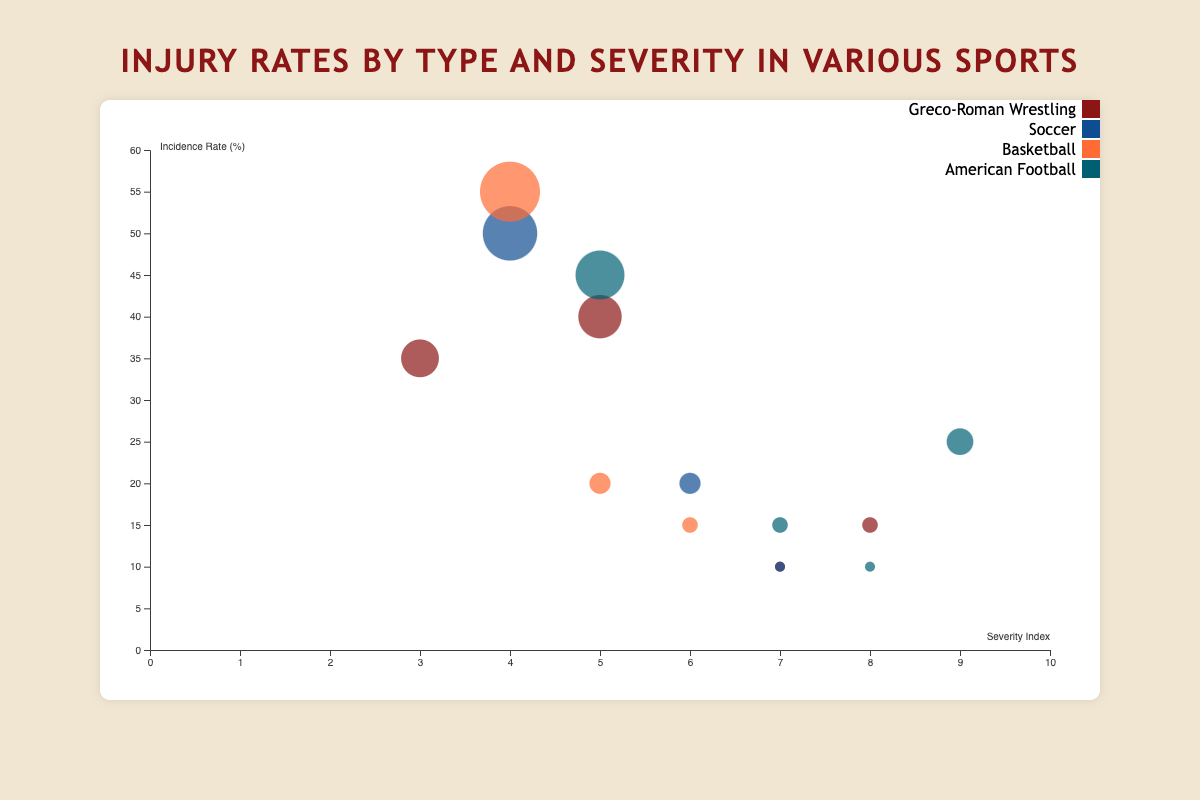What is the title of the figure? The title is usually located at the top of the chart and provides a summary of what the chart is about. In this case, the title is "Injury Rates by Type and Severity in Various Sports."
Answer: Injury Rates by Type and Severity in Various Sports What is the range of incidence rates depicted in the y-axis? The y-axis represents the incidence rate and is labeled accordingly with values. The range starts from 0% to 60%.
Answer: 0% to 60% Which sport has the highest incidence rate for sprains? By observing the bubbles related to "Sprains," we can compare the sizes. The largest bubble for "Sprains" belongs to Basketball with an incidence rate of 55%.
Answer: Basketball What is the color representing Greco-Roman Wrestling in the chart? Each sport is represented by a different color. According to the legend, Greco-Roman Wrestling is represented by the maroon color.
Answer: Maroon How many types of injuries are recorded for Basketball in the chart? Each entry has a sport and injury type. Counting the unique injury types for Basketball, there are three: Sprains, Fractures, and Tendinitis.
Answer: 3 Which injury type has the highest severity index in the chart? The severity index is on the x-axis. By looking at the bubbles furthest to the right, Concussions in American Football have the highest severity index of 9.
Answer: Concussions What is the average incidence rate of fractures across all sports? Summing up the incidence rates of fractures (Greco-Roman Wrestling: 15, Soccer: 20, Basketball: 15, American Football: 15) and dividing by the number of sports (4): (15 + 20 + 15 + 15)/4 = 65/4 = 16.25%
Answer: 16.25% Compare the severity index of sprains in Soccer and American Football. Which is higher? By checking the severity index for "Sprains" in these sports, Soccer has a severity index of 4, while American Football has 5, making American Football higher.
Answer: American Football What is the incidence rate for lacerations in Greco-Roman Wrestling? The chart shows a specific bubble for lacerations in Greco-Roman Wrestling, which has an incidence rate of 35%.
Answer: 35% Identify the sports with an incidence rate for dislocations and their respective rates. Observing the chart, Greco-Roman Wrestling and American Football have bubbles for dislocations with incidence rates of 10% each.
Answer: Greco-Roman Wrestling: 10%, American Football: 10% 